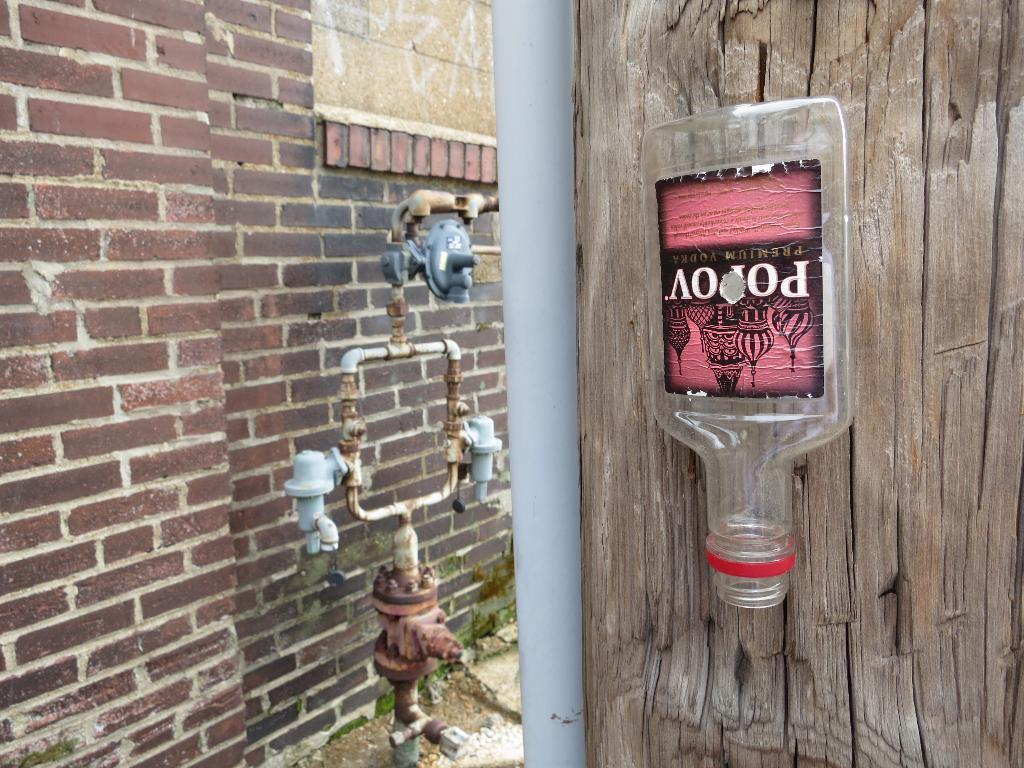What can be seen in the image that is typically used for holding liquids? There is a bottle in the image. What is located in the image that appears to be a collection of items? There is a pile in the image. What type of equipment is present in the image? There is a machine in the image. What material is the object on the right side of the image made of? The wooden object on the right side of the image is made of wood. What type of structure can be seen on the left side of the image? There is a brick wall on the left side of the image. Who is the porter in the image? There is no porter present in the image. What type of patch can be seen on the wooden object in the image? There is no patch visible on the wooden object in the image. 